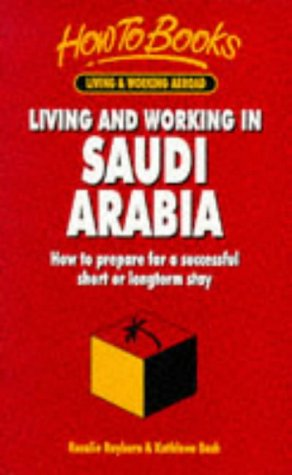Who is the author of this book? The book 'Living & Working in Saudi Arabia' is authored by Rosalie Rayburn, who provides invaluable insights for anyone planning to stay in Saudi Arabia. 